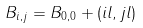<formula> <loc_0><loc_0><loc_500><loc_500>B _ { i , j } = B _ { 0 , 0 } + ( i l , j l )</formula> 